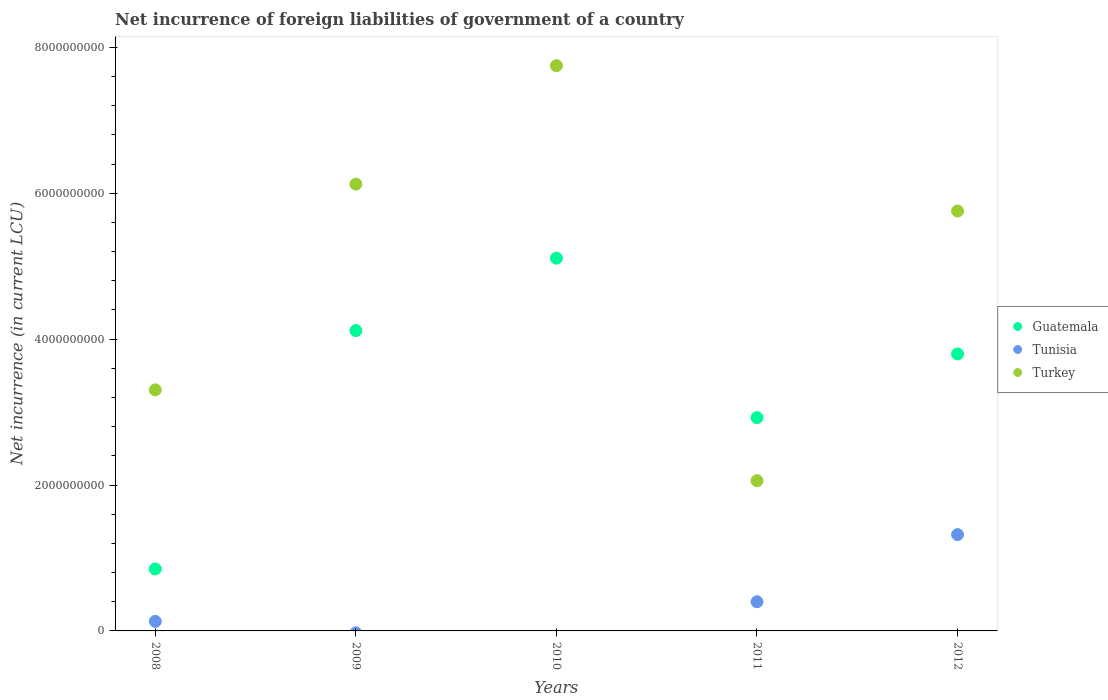Is the number of dotlines equal to the number of legend labels?
Your response must be concise. No. What is the net incurrence of foreign liabilities in Guatemala in 2008?
Provide a succinct answer. 8.50e+08. Across all years, what is the maximum net incurrence of foreign liabilities in Turkey?
Your response must be concise. 7.75e+09. Across all years, what is the minimum net incurrence of foreign liabilities in Guatemala?
Your answer should be very brief. 8.50e+08. What is the total net incurrence of foreign liabilities in Turkey in the graph?
Offer a very short reply. 2.50e+1. What is the difference between the net incurrence of foreign liabilities in Turkey in 2008 and that in 2010?
Your answer should be very brief. -4.44e+09. What is the difference between the net incurrence of foreign liabilities in Tunisia in 2011 and the net incurrence of foreign liabilities in Guatemala in 2012?
Ensure brevity in your answer.  -3.40e+09. What is the average net incurrence of foreign liabilities in Turkey per year?
Your answer should be very brief. 5.00e+09. In the year 2012, what is the difference between the net incurrence of foreign liabilities in Turkey and net incurrence of foreign liabilities in Guatemala?
Offer a very short reply. 1.96e+09. What is the ratio of the net incurrence of foreign liabilities in Turkey in 2009 to that in 2012?
Offer a very short reply. 1.06. What is the difference between the highest and the second highest net incurrence of foreign liabilities in Guatemala?
Provide a short and direct response. 9.92e+08. What is the difference between the highest and the lowest net incurrence of foreign liabilities in Turkey?
Make the answer very short. 5.69e+09. In how many years, is the net incurrence of foreign liabilities in Turkey greater than the average net incurrence of foreign liabilities in Turkey taken over all years?
Provide a short and direct response. 3. Is the sum of the net incurrence of foreign liabilities in Turkey in 2009 and 2010 greater than the maximum net incurrence of foreign liabilities in Guatemala across all years?
Provide a short and direct response. Yes. Is it the case that in every year, the sum of the net incurrence of foreign liabilities in Turkey and net incurrence of foreign liabilities in Guatemala  is greater than the net incurrence of foreign liabilities in Tunisia?
Ensure brevity in your answer.  Yes. Does the net incurrence of foreign liabilities in Tunisia monotonically increase over the years?
Your response must be concise. No. Is the net incurrence of foreign liabilities in Guatemala strictly greater than the net incurrence of foreign liabilities in Turkey over the years?
Give a very brief answer. No. Is the net incurrence of foreign liabilities in Turkey strictly less than the net incurrence of foreign liabilities in Guatemala over the years?
Offer a very short reply. No. How many dotlines are there?
Offer a terse response. 3. Are the values on the major ticks of Y-axis written in scientific E-notation?
Offer a terse response. No. Does the graph contain grids?
Your answer should be compact. No. Where does the legend appear in the graph?
Offer a very short reply. Center right. How many legend labels are there?
Offer a terse response. 3. How are the legend labels stacked?
Make the answer very short. Vertical. What is the title of the graph?
Provide a short and direct response. Net incurrence of foreign liabilities of government of a country. What is the label or title of the X-axis?
Provide a succinct answer. Years. What is the label or title of the Y-axis?
Keep it short and to the point. Net incurrence (in current LCU). What is the Net incurrence (in current LCU) in Guatemala in 2008?
Give a very brief answer. 8.50e+08. What is the Net incurrence (in current LCU) of Tunisia in 2008?
Ensure brevity in your answer.  1.31e+08. What is the Net incurrence (in current LCU) in Turkey in 2008?
Your answer should be compact. 3.30e+09. What is the Net incurrence (in current LCU) in Guatemala in 2009?
Provide a succinct answer. 4.12e+09. What is the Net incurrence (in current LCU) of Turkey in 2009?
Provide a short and direct response. 6.12e+09. What is the Net incurrence (in current LCU) in Guatemala in 2010?
Provide a short and direct response. 5.11e+09. What is the Net incurrence (in current LCU) of Tunisia in 2010?
Provide a succinct answer. 0. What is the Net incurrence (in current LCU) of Turkey in 2010?
Your response must be concise. 7.75e+09. What is the Net incurrence (in current LCU) of Guatemala in 2011?
Give a very brief answer. 2.92e+09. What is the Net incurrence (in current LCU) in Tunisia in 2011?
Your response must be concise. 4.00e+08. What is the Net incurrence (in current LCU) in Turkey in 2011?
Your answer should be compact. 2.06e+09. What is the Net incurrence (in current LCU) in Guatemala in 2012?
Your response must be concise. 3.80e+09. What is the Net incurrence (in current LCU) in Tunisia in 2012?
Offer a terse response. 1.32e+09. What is the Net incurrence (in current LCU) of Turkey in 2012?
Keep it short and to the point. 5.76e+09. Across all years, what is the maximum Net incurrence (in current LCU) in Guatemala?
Offer a terse response. 5.11e+09. Across all years, what is the maximum Net incurrence (in current LCU) of Tunisia?
Your answer should be compact. 1.32e+09. Across all years, what is the maximum Net incurrence (in current LCU) in Turkey?
Keep it short and to the point. 7.75e+09. Across all years, what is the minimum Net incurrence (in current LCU) of Guatemala?
Your answer should be compact. 8.50e+08. Across all years, what is the minimum Net incurrence (in current LCU) in Tunisia?
Your answer should be compact. 0. Across all years, what is the minimum Net incurrence (in current LCU) of Turkey?
Ensure brevity in your answer.  2.06e+09. What is the total Net incurrence (in current LCU) in Guatemala in the graph?
Your response must be concise. 1.68e+1. What is the total Net incurrence (in current LCU) in Tunisia in the graph?
Ensure brevity in your answer.  1.85e+09. What is the total Net incurrence (in current LCU) in Turkey in the graph?
Ensure brevity in your answer.  2.50e+1. What is the difference between the Net incurrence (in current LCU) of Guatemala in 2008 and that in 2009?
Your answer should be very brief. -3.27e+09. What is the difference between the Net incurrence (in current LCU) in Turkey in 2008 and that in 2009?
Keep it short and to the point. -2.82e+09. What is the difference between the Net incurrence (in current LCU) in Guatemala in 2008 and that in 2010?
Offer a very short reply. -4.26e+09. What is the difference between the Net incurrence (in current LCU) in Turkey in 2008 and that in 2010?
Ensure brevity in your answer.  -4.44e+09. What is the difference between the Net incurrence (in current LCU) of Guatemala in 2008 and that in 2011?
Your answer should be very brief. -2.07e+09. What is the difference between the Net incurrence (in current LCU) of Tunisia in 2008 and that in 2011?
Offer a very short reply. -2.69e+08. What is the difference between the Net incurrence (in current LCU) in Turkey in 2008 and that in 2011?
Your response must be concise. 1.25e+09. What is the difference between the Net incurrence (in current LCU) in Guatemala in 2008 and that in 2012?
Your response must be concise. -2.95e+09. What is the difference between the Net incurrence (in current LCU) in Tunisia in 2008 and that in 2012?
Your answer should be very brief. -1.19e+09. What is the difference between the Net incurrence (in current LCU) of Turkey in 2008 and that in 2012?
Keep it short and to the point. -2.45e+09. What is the difference between the Net incurrence (in current LCU) in Guatemala in 2009 and that in 2010?
Make the answer very short. -9.92e+08. What is the difference between the Net incurrence (in current LCU) of Turkey in 2009 and that in 2010?
Your answer should be very brief. -1.62e+09. What is the difference between the Net incurrence (in current LCU) of Guatemala in 2009 and that in 2011?
Your response must be concise. 1.19e+09. What is the difference between the Net incurrence (in current LCU) in Turkey in 2009 and that in 2011?
Provide a short and direct response. 4.07e+09. What is the difference between the Net incurrence (in current LCU) in Guatemala in 2009 and that in 2012?
Offer a very short reply. 3.20e+08. What is the difference between the Net incurrence (in current LCU) of Turkey in 2009 and that in 2012?
Give a very brief answer. 3.69e+08. What is the difference between the Net incurrence (in current LCU) of Guatemala in 2010 and that in 2011?
Keep it short and to the point. 2.19e+09. What is the difference between the Net incurrence (in current LCU) in Turkey in 2010 and that in 2011?
Your response must be concise. 5.69e+09. What is the difference between the Net incurrence (in current LCU) of Guatemala in 2010 and that in 2012?
Give a very brief answer. 1.31e+09. What is the difference between the Net incurrence (in current LCU) in Turkey in 2010 and that in 2012?
Provide a succinct answer. 1.99e+09. What is the difference between the Net incurrence (in current LCU) in Guatemala in 2011 and that in 2012?
Make the answer very short. -8.74e+08. What is the difference between the Net incurrence (in current LCU) in Tunisia in 2011 and that in 2012?
Keep it short and to the point. -9.20e+08. What is the difference between the Net incurrence (in current LCU) of Turkey in 2011 and that in 2012?
Provide a succinct answer. -3.70e+09. What is the difference between the Net incurrence (in current LCU) of Guatemala in 2008 and the Net incurrence (in current LCU) of Turkey in 2009?
Provide a short and direct response. -5.28e+09. What is the difference between the Net incurrence (in current LCU) of Tunisia in 2008 and the Net incurrence (in current LCU) of Turkey in 2009?
Give a very brief answer. -5.99e+09. What is the difference between the Net incurrence (in current LCU) in Guatemala in 2008 and the Net incurrence (in current LCU) in Turkey in 2010?
Your response must be concise. -6.90e+09. What is the difference between the Net incurrence (in current LCU) of Tunisia in 2008 and the Net incurrence (in current LCU) of Turkey in 2010?
Keep it short and to the point. -7.62e+09. What is the difference between the Net incurrence (in current LCU) in Guatemala in 2008 and the Net incurrence (in current LCU) in Tunisia in 2011?
Provide a succinct answer. 4.50e+08. What is the difference between the Net incurrence (in current LCU) of Guatemala in 2008 and the Net incurrence (in current LCU) of Turkey in 2011?
Provide a succinct answer. -1.21e+09. What is the difference between the Net incurrence (in current LCU) in Tunisia in 2008 and the Net incurrence (in current LCU) in Turkey in 2011?
Keep it short and to the point. -1.93e+09. What is the difference between the Net incurrence (in current LCU) in Guatemala in 2008 and the Net incurrence (in current LCU) in Tunisia in 2012?
Give a very brief answer. -4.71e+08. What is the difference between the Net incurrence (in current LCU) in Guatemala in 2008 and the Net incurrence (in current LCU) in Turkey in 2012?
Make the answer very short. -4.91e+09. What is the difference between the Net incurrence (in current LCU) in Tunisia in 2008 and the Net incurrence (in current LCU) in Turkey in 2012?
Make the answer very short. -5.63e+09. What is the difference between the Net incurrence (in current LCU) in Guatemala in 2009 and the Net incurrence (in current LCU) in Turkey in 2010?
Your response must be concise. -3.63e+09. What is the difference between the Net incurrence (in current LCU) in Guatemala in 2009 and the Net incurrence (in current LCU) in Tunisia in 2011?
Keep it short and to the point. 3.72e+09. What is the difference between the Net incurrence (in current LCU) of Guatemala in 2009 and the Net incurrence (in current LCU) of Turkey in 2011?
Provide a short and direct response. 2.06e+09. What is the difference between the Net incurrence (in current LCU) in Guatemala in 2009 and the Net incurrence (in current LCU) in Tunisia in 2012?
Provide a succinct answer. 2.80e+09. What is the difference between the Net incurrence (in current LCU) in Guatemala in 2009 and the Net incurrence (in current LCU) in Turkey in 2012?
Make the answer very short. -1.64e+09. What is the difference between the Net incurrence (in current LCU) of Guatemala in 2010 and the Net incurrence (in current LCU) of Tunisia in 2011?
Your answer should be very brief. 4.71e+09. What is the difference between the Net incurrence (in current LCU) of Guatemala in 2010 and the Net incurrence (in current LCU) of Turkey in 2011?
Offer a terse response. 3.05e+09. What is the difference between the Net incurrence (in current LCU) of Guatemala in 2010 and the Net incurrence (in current LCU) of Tunisia in 2012?
Ensure brevity in your answer.  3.79e+09. What is the difference between the Net incurrence (in current LCU) of Guatemala in 2010 and the Net incurrence (in current LCU) of Turkey in 2012?
Ensure brevity in your answer.  -6.46e+08. What is the difference between the Net incurrence (in current LCU) in Guatemala in 2011 and the Net incurrence (in current LCU) in Tunisia in 2012?
Your answer should be compact. 1.60e+09. What is the difference between the Net incurrence (in current LCU) of Guatemala in 2011 and the Net incurrence (in current LCU) of Turkey in 2012?
Your response must be concise. -2.83e+09. What is the difference between the Net incurrence (in current LCU) in Tunisia in 2011 and the Net incurrence (in current LCU) in Turkey in 2012?
Your answer should be very brief. -5.36e+09. What is the average Net incurrence (in current LCU) in Guatemala per year?
Offer a very short reply. 3.36e+09. What is the average Net incurrence (in current LCU) of Tunisia per year?
Provide a succinct answer. 3.70e+08. What is the average Net incurrence (in current LCU) in Turkey per year?
Keep it short and to the point. 5.00e+09. In the year 2008, what is the difference between the Net incurrence (in current LCU) of Guatemala and Net incurrence (in current LCU) of Tunisia?
Your response must be concise. 7.19e+08. In the year 2008, what is the difference between the Net incurrence (in current LCU) of Guatemala and Net incurrence (in current LCU) of Turkey?
Offer a very short reply. -2.46e+09. In the year 2008, what is the difference between the Net incurrence (in current LCU) of Tunisia and Net incurrence (in current LCU) of Turkey?
Make the answer very short. -3.17e+09. In the year 2009, what is the difference between the Net incurrence (in current LCU) in Guatemala and Net incurrence (in current LCU) in Turkey?
Your answer should be very brief. -2.01e+09. In the year 2010, what is the difference between the Net incurrence (in current LCU) of Guatemala and Net incurrence (in current LCU) of Turkey?
Your answer should be compact. -2.64e+09. In the year 2011, what is the difference between the Net incurrence (in current LCU) in Guatemala and Net incurrence (in current LCU) in Tunisia?
Your answer should be compact. 2.52e+09. In the year 2011, what is the difference between the Net incurrence (in current LCU) in Guatemala and Net incurrence (in current LCU) in Turkey?
Your answer should be compact. 8.64e+08. In the year 2011, what is the difference between the Net incurrence (in current LCU) of Tunisia and Net incurrence (in current LCU) of Turkey?
Your response must be concise. -1.66e+09. In the year 2012, what is the difference between the Net incurrence (in current LCU) in Guatemala and Net incurrence (in current LCU) in Tunisia?
Keep it short and to the point. 2.48e+09. In the year 2012, what is the difference between the Net incurrence (in current LCU) of Guatemala and Net incurrence (in current LCU) of Turkey?
Provide a short and direct response. -1.96e+09. In the year 2012, what is the difference between the Net incurrence (in current LCU) in Tunisia and Net incurrence (in current LCU) in Turkey?
Provide a succinct answer. -4.44e+09. What is the ratio of the Net incurrence (in current LCU) in Guatemala in 2008 to that in 2009?
Ensure brevity in your answer.  0.21. What is the ratio of the Net incurrence (in current LCU) in Turkey in 2008 to that in 2009?
Ensure brevity in your answer.  0.54. What is the ratio of the Net incurrence (in current LCU) of Guatemala in 2008 to that in 2010?
Provide a succinct answer. 0.17. What is the ratio of the Net incurrence (in current LCU) in Turkey in 2008 to that in 2010?
Ensure brevity in your answer.  0.43. What is the ratio of the Net incurrence (in current LCU) of Guatemala in 2008 to that in 2011?
Your answer should be compact. 0.29. What is the ratio of the Net incurrence (in current LCU) of Tunisia in 2008 to that in 2011?
Provide a short and direct response. 0.33. What is the ratio of the Net incurrence (in current LCU) in Turkey in 2008 to that in 2011?
Offer a very short reply. 1.6. What is the ratio of the Net incurrence (in current LCU) of Guatemala in 2008 to that in 2012?
Your answer should be compact. 0.22. What is the ratio of the Net incurrence (in current LCU) of Tunisia in 2008 to that in 2012?
Make the answer very short. 0.1. What is the ratio of the Net incurrence (in current LCU) of Turkey in 2008 to that in 2012?
Keep it short and to the point. 0.57. What is the ratio of the Net incurrence (in current LCU) of Guatemala in 2009 to that in 2010?
Your answer should be compact. 0.81. What is the ratio of the Net incurrence (in current LCU) in Turkey in 2009 to that in 2010?
Offer a terse response. 0.79. What is the ratio of the Net incurrence (in current LCU) of Guatemala in 2009 to that in 2011?
Provide a succinct answer. 1.41. What is the ratio of the Net incurrence (in current LCU) of Turkey in 2009 to that in 2011?
Make the answer very short. 2.97. What is the ratio of the Net incurrence (in current LCU) in Guatemala in 2009 to that in 2012?
Provide a succinct answer. 1.08. What is the ratio of the Net incurrence (in current LCU) in Turkey in 2009 to that in 2012?
Keep it short and to the point. 1.06. What is the ratio of the Net incurrence (in current LCU) in Guatemala in 2010 to that in 2011?
Your response must be concise. 1.75. What is the ratio of the Net incurrence (in current LCU) in Turkey in 2010 to that in 2011?
Make the answer very short. 3.76. What is the ratio of the Net incurrence (in current LCU) in Guatemala in 2010 to that in 2012?
Keep it short and to the point. 1.35. What is the ratio of the Net incurrence (in current LCU) in Turkey in 2010 to that in 2012?
Your answer should be very brief. 1.35. What is the ratio of the Net incurrence (in current LCU) of Guatemala in 2011 to that in 2012?
Your answer should be compact. 0.77. What is the ratio of the Net incurrence (in current LCU) of Tunisia in 2011 to that in 2012?
Make the answer very short. 0.3. What is the ratio of the Net incurrence (in current LCU) in Turkey in 2011 to that in 2012?
Provide a succinct answer. 0.36. What is the difference between the highest and the second highest Net incurrence (in current LCU) of Guatemala?
Ensure brevity in your answer.  9.92e+08. What is the difference between the highest and the second highest Net incurrence (in current LCU) of Tunisia?
Make the answer very short. 9.20e+08. What is the difference between the highest and the second highest Net incurrence (in current LCU) in Turkey?
Make the answer very short. 1.62e+09. What is the difference between the highest and the lowest Net incurrence (in current LCU) of Guatemala?
Make the answer very short. 4.26e+09. What is the difference between the highest and the lowest Net incurrence (in current LCU) of Tunisia?
Keep it short and to the point. 1.32e+09. What is the difference between the highest and the lowest Net incurrence (in current LCU) of Turkey?
Keep it short and to the point. 5.69e+09. 